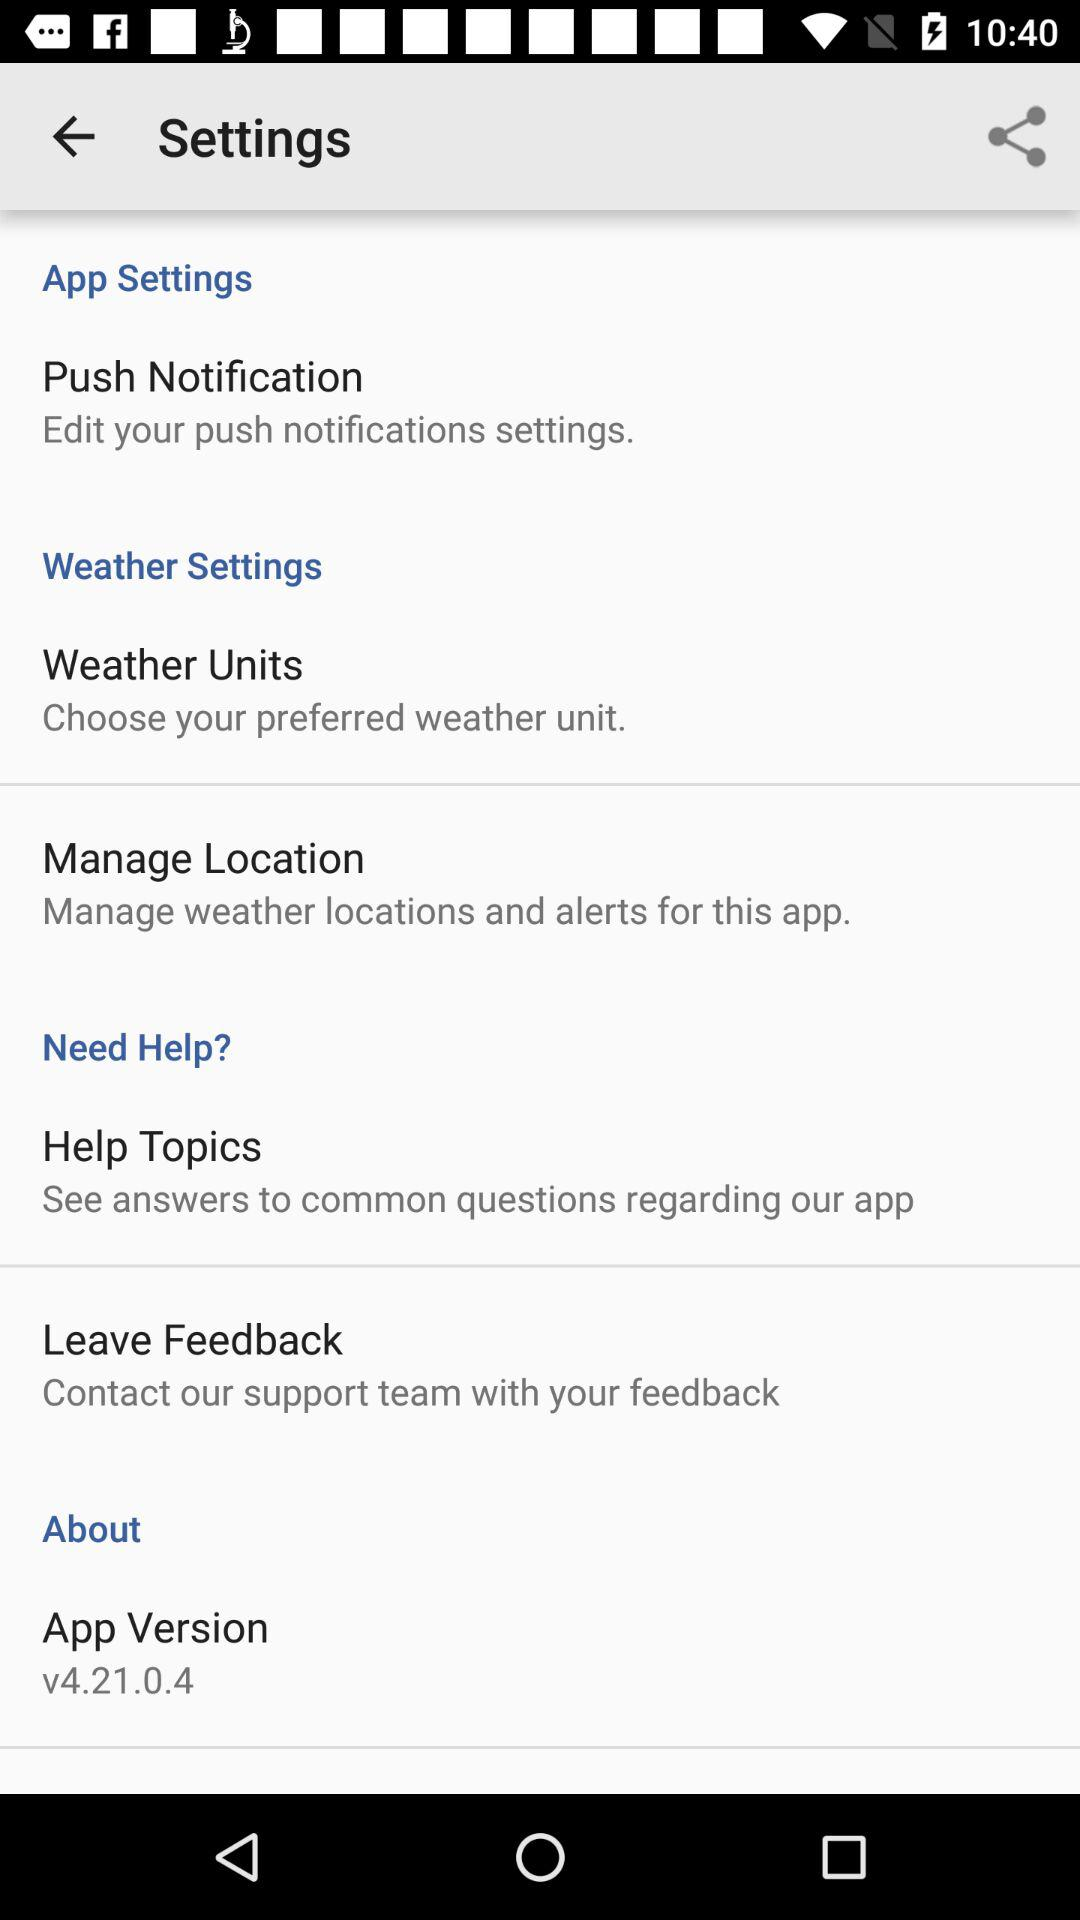What's the application version? The application version is 4.21.0.4. 